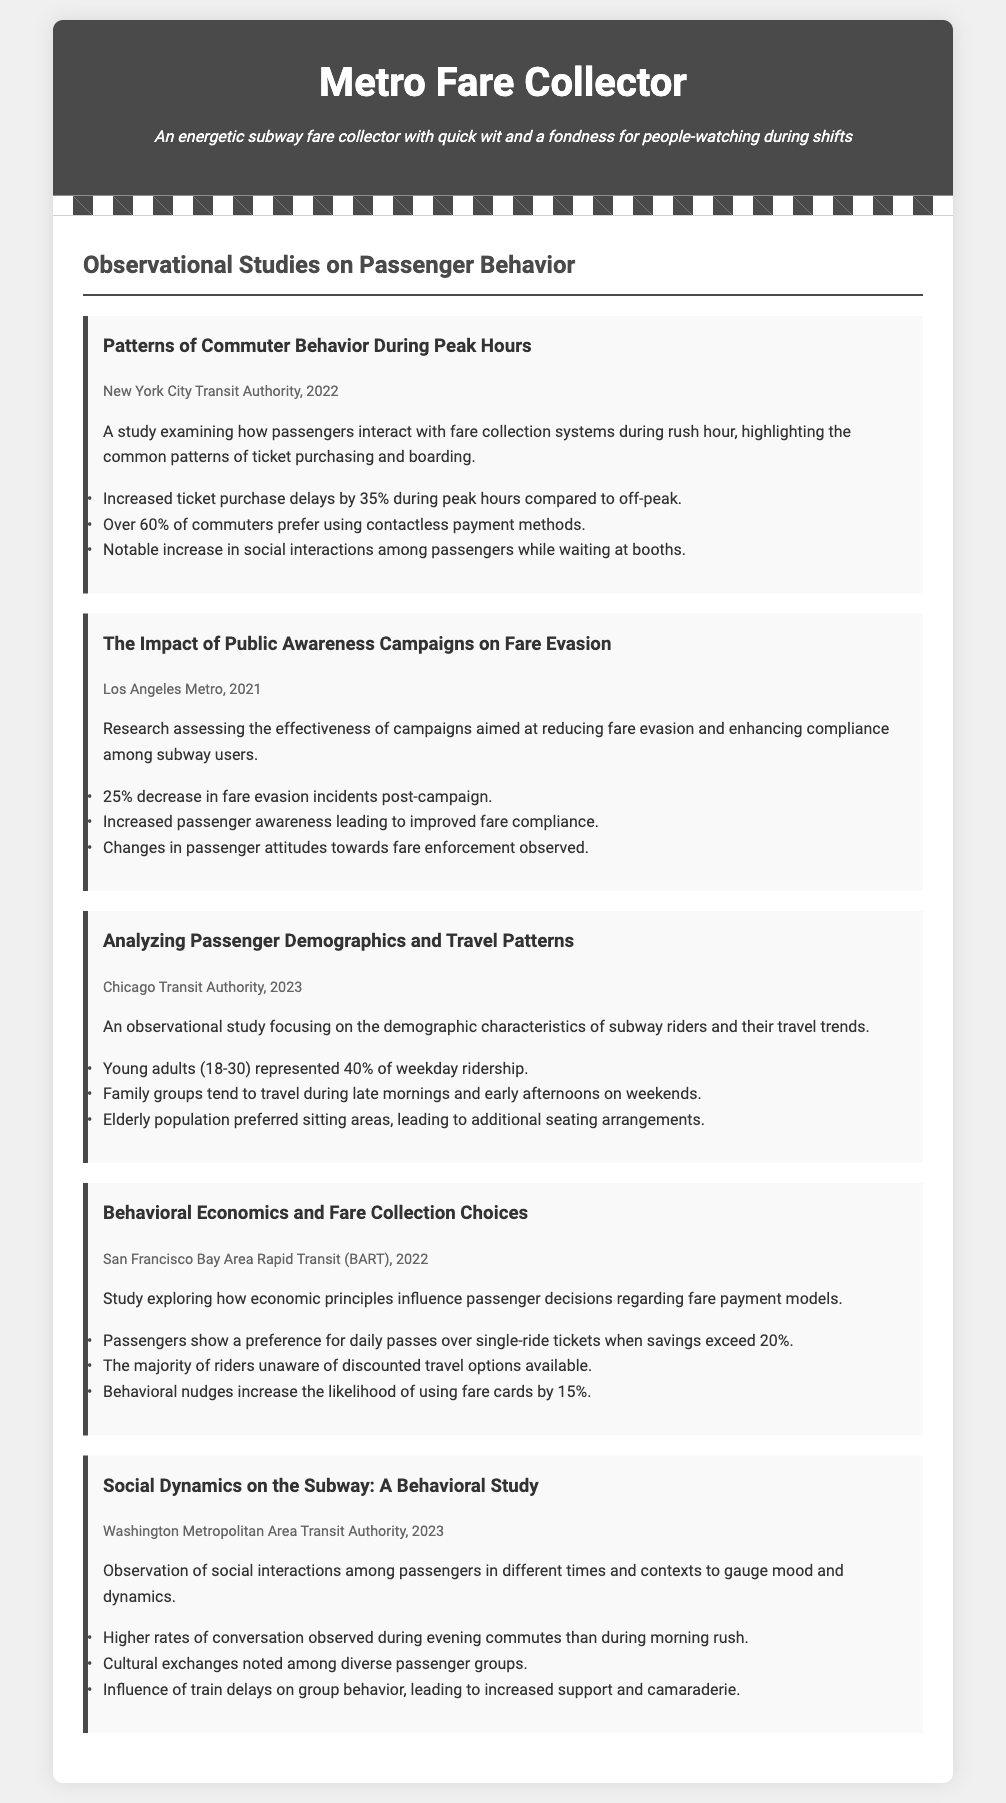What is the title of the first study? The title of the first study is presented in the document, which is "Patterns of Commuter Behavior During Peak Hours."
Answer: Patterns of Commuter Behavior During Peak Hours Who conducted the second study? The second study was conducted by Los Angeles Metro, as noted in the study information.
Answer: Los Angeles Metro What percentage of fare evasion incidents decreased after the public awareness campaign? The document states a 25% decrease in fare evasion incidents post-campaign.
Answer: 25% In which year was the study on passenger demographics conducted? The year for the study on passenger demographics is explicitly mentioned in the document as 2023.
Answer: 2023 Which payment method is preferred by over 60% of commuters? According to the findings, over 60% of commuters prefer using contactless payment methods.
Answer: contactless payment methods What was the common time for family groups to travel on weekends? The study indicates family groups tend to travel during late mornings and early afternoons on weekends.
Answer: late mornings and early afternoons What type of fare payment model do passengers prefer when savings exceed 20%? The findings highlight that passengers prefer daily passes over single-ride tickets when savings exceed 20%.
Answer: daily passes What is a noted effect of train delays on passenger behavior? The document notes that train delays influence group behavior, leading to increased support and camaraderie among passengers.
Answer: increased support and camaraderie 